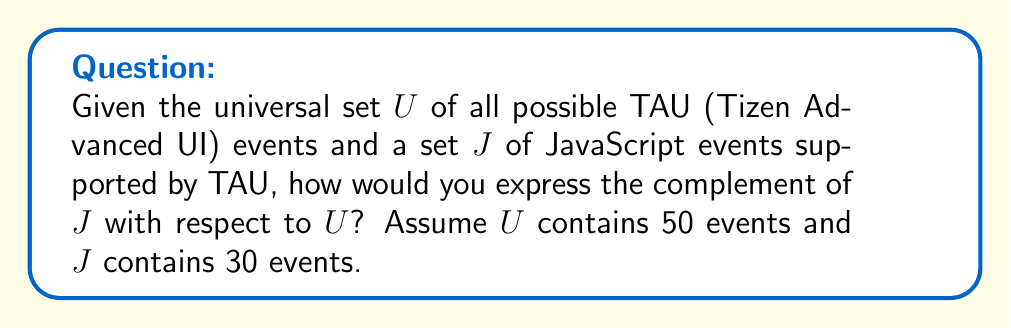Teach me how to tackle this problem. To solve this problem, we need to understand the concept of set complement and apply it to the given scenario. Let's break it down step-by-step:

1. Define the sets:
   - $U$ is the universal set of all possible TAU events (50 events)
   - $J$ is the set of JavaScript events supported by TAU (30 events)

2. The complement of set $J$ with respect to $U$, denoted as $J^c$ or $U \setminus J$, is the set of all elements in $U$ that are not in $J$.

3. To find the number of elements in $J^c$:
   $$|J^c| = |U| - |J|$$
   Where $|U|$ is the number of elements in $U$, and $|J|$ is the number of elements in $J$.

4. Substitute the given values:
   $$|J^c| = 50 - 30 = 20$$

5. The complement $J^c$ can be expressed in set-builder notation as:
   $$J^c = \{x \in U : x \notin J\}$$

This means $J^c$ contains all the TAU events that are not JavaScript events, which would include events specific to Tizen or other non-JavaScript events in the TAU library.
Answer: $J^c = \{x \in U : x \notin J\}$, where $|J^c| = 20$ 